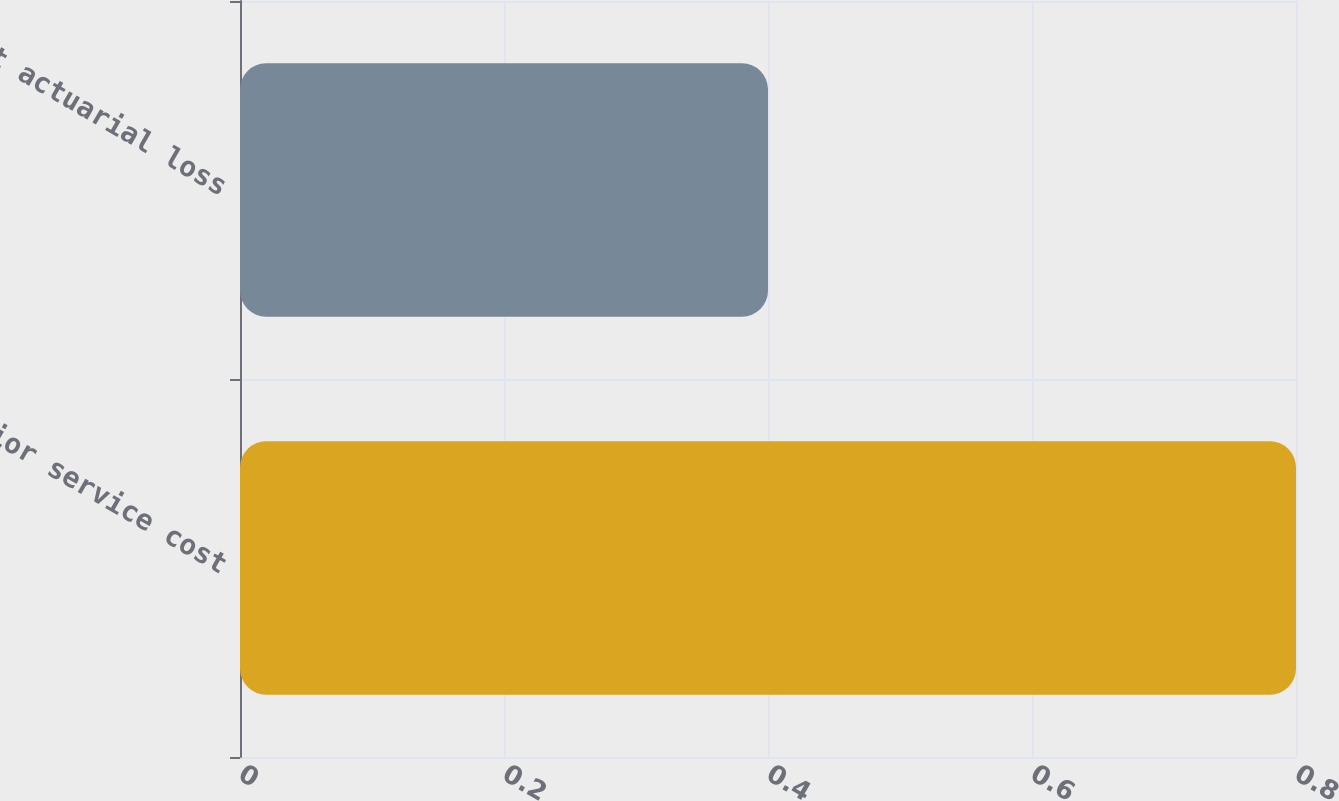Convert chart. <chart><loc_0><loc_0><loc_500><loc_500><bar_chart><fcel>Prior service cost<fcel>Net actuarial loss<nl><fcel>0.8<fcel>0.4<nl></chart> 